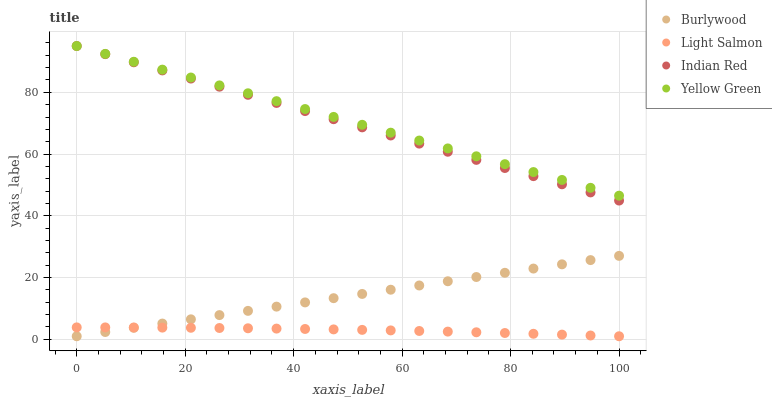Does Light Salmon have the minimum area under the curve?
Answer yes or no. Yes. Does Yellow Green have the maximum area under the curve?
Answer yes or no. Yes. Does Yellow Green have the minimum area under the curve?
Answer yes or no. No. Does Light Salmon have the maximum area under the curve?
Answer yes or no. No. Is Burlywood the smoothest?
Answer yes or no. Yes. Is Light Salmon the roughest?
Answer yes or no. Yes. Is Yellow Green the smoothest?
Answer yes or no. No. Is Yellow Green the roughest?
Answer yes or no. No. Does Burlywood have the lowest value?
Answer yes or no. Yes. Does Yellow Green have the lowest value?
Answer yes or no. No. Does Indian Red have the highest value?
Answer yes or no. Yes. Does Light Salmon have the highest value?
Answer yes or no. No. Is Burlywood less than Indian Red?
Answer yes or no. Yes. Is Yellow Green greater than Burlywood?
Answer yes or no. Yes. Does Burlywood intersect Light Salmon?
Answer yes or no. Yes. Is Burlywood less than Light Salmon?
Answer yes or no. No. Is Burlywood greater than Light Salmon?
Answer yes or no. No. Does Burlywood intersect Indian Red?
Answer yes or no. No. 